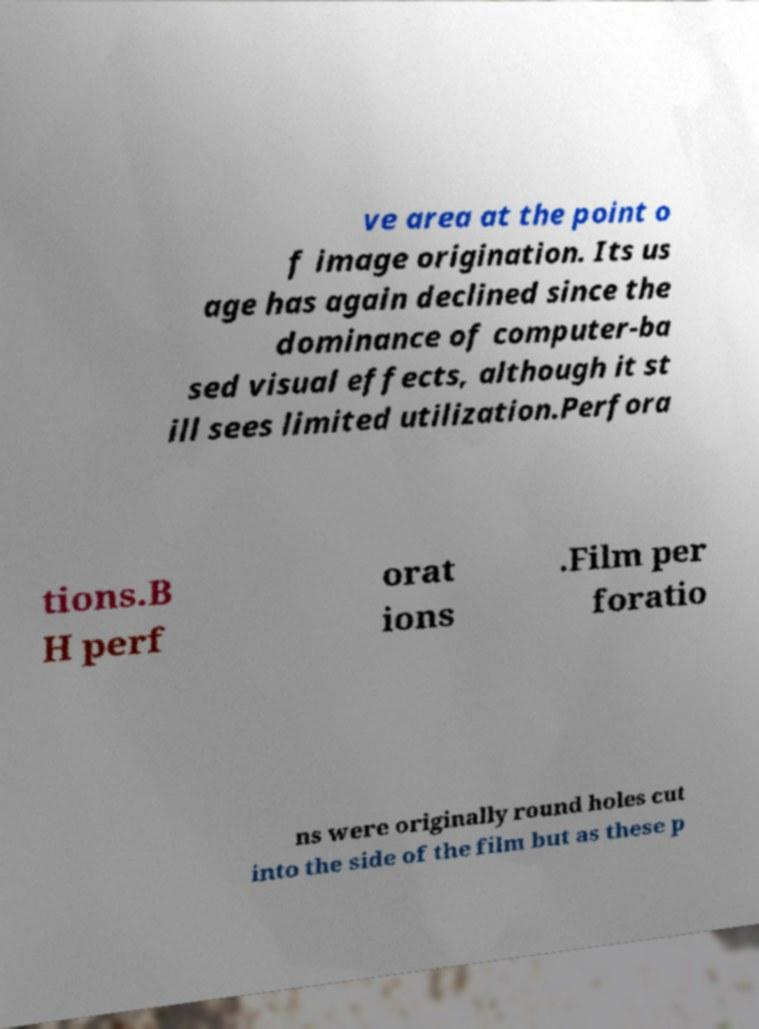There's text embedded in this image that I need extracted. Can you transcribe it verbatim? ve area at the point o f image origination. Its us age has again declined since the dominance of computer-ba sed visual effects, although it st ill sees limited utilization.Perfora tions.B H perf orat ions .Film per foratio ns were originally round holes cut into the side of the film but as these p 